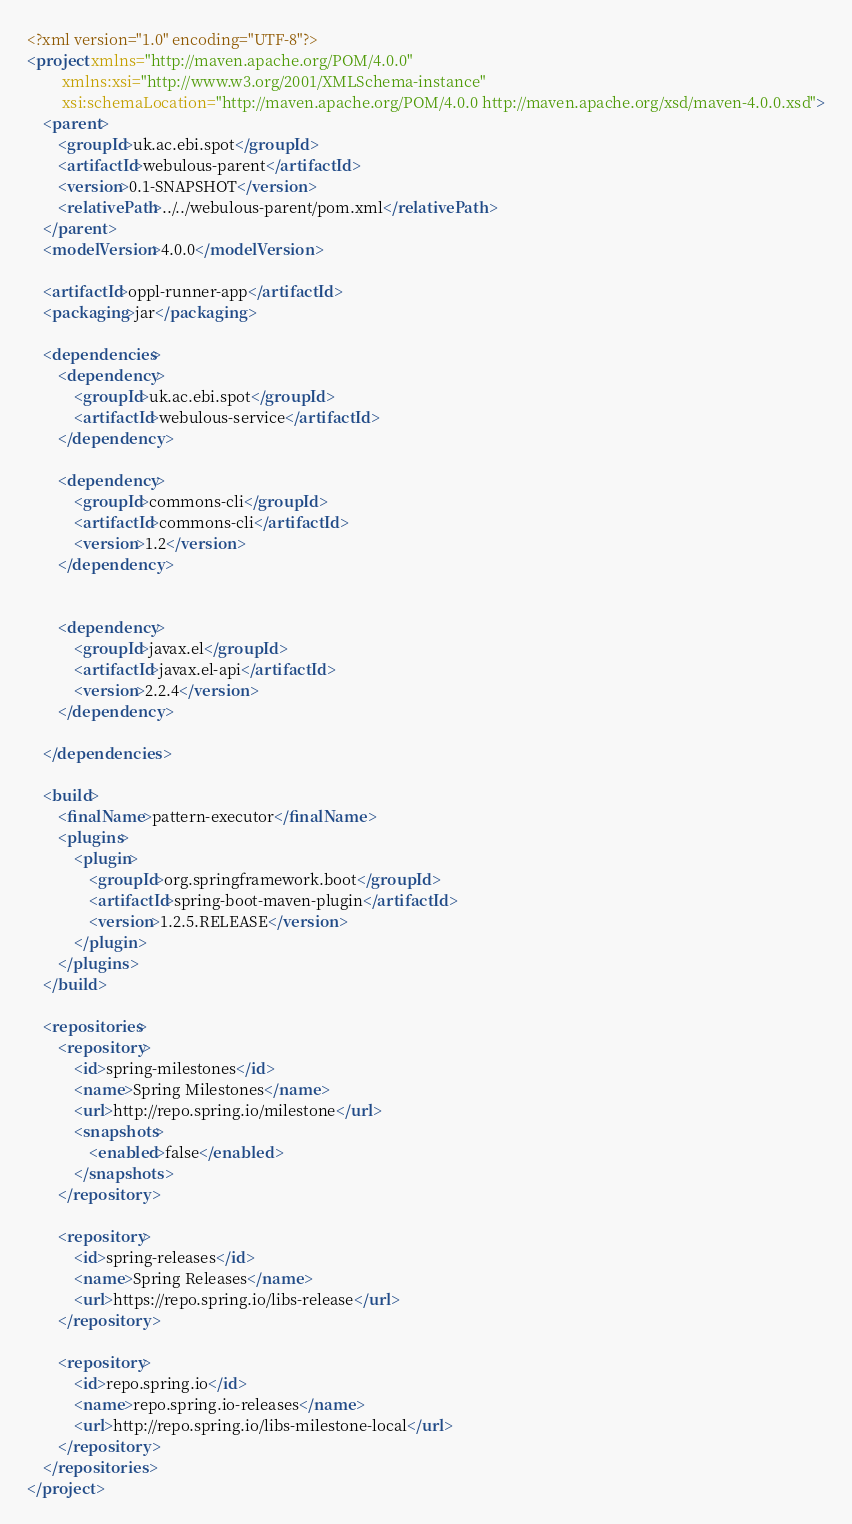<code> <loc_0><loc_0><loc_500><loc_500><_XML_><?xml version="1.0" encoding="UTF-8"?>
<project xmlns="http://maven.apache.org/POM/4.0.0"
         xmlns:xsi="http://www.w3.org/2001/XMLSchema-instance"
         xsi:schemaLocation="http://maven.apache.org/POM/4.0.0 http://maven.apache.org/xsd/maven-4.0.0.xsd">
    <parent>
        <groupId>uk.ac.ebi.spot</groupId>
        <artifactId>webulous-parent</artifactId>
        <version>0.1-SNAPSHOT</version>
        <relativePath>../../webulous-parent/pom.xml</relativePath>
    </parent>
    <modelVersion>4.0.0</modelVersion>

    <artifactId>oppl-runner-app</artifactId>
    <packaging>jar</packaging>

    <dependencies>
        <dependency>
            <groupId>uk.ac.ebi.spot</groupId>
            <artifactId>webulous-service</artifactId>
        </dependency>

        <dependency>
            <groupId>commons-cli</groupId>
            <artifactId>commons-cli</artifactId>
            <version>1.2</version>
        </dependency>


        <dependency>
            <groupId>javax.el</groupId>
            <artifactId>javax.el-api</artifactId>
            <version>2.2.4</version>
        </dependency>

    </dependencies>

    <build>
        <finalName>pattern-executor</finalName>
        <plugins>
            <plugin>
                <groupId>org.springframework.boot</groupId>
                <artifactId>spring-boot-maven-plugin</artifactId>
                <version>1.2.5.RELEASE</version>
            </plugin>
        </plugins>
    </build>

    <repositories>
        <repository>
            <id>spring-milestones</id>
            <name>Spring Milestones</name>
            <url>http://repo.spring.io/milestone</url>
            <snapshots>
                <enabled>false</enabled>
            </snapshots>
        </repository>

        <repository>
            <id>spring-releases</id>
            <name>Spring Releases</name>
            <url>https://repo.spring.io/libs-release</url>
        </repository>

        <repository>
            <id>repo.spring.io</id>
            <name>repo.spring.io-releases</name>
            <url>http://repo.spring.io/libs-milestone-local</url>
        </repository>
    </repositories>
</project></code> 